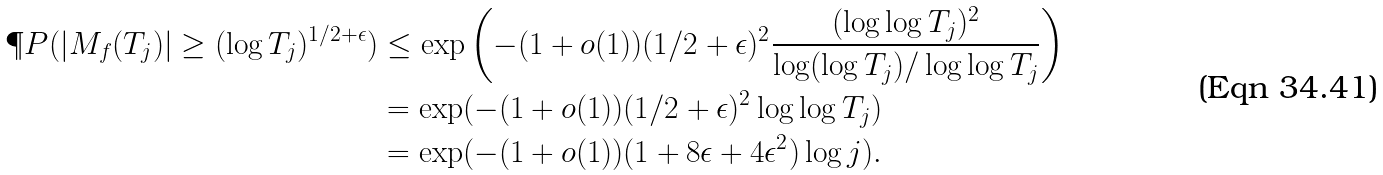<formula> <loc_0><loc_0><loc_500><loc_500>\P P ( | M _ { f } ( T _ { j } ) | \geq ( \log T _ { j } ) ^ { 1 / 2 + \epsilon } ) & \leq \exp \left ( - ( 1 + o ( 1 ) ) ( 1 / 2 + \epsilon ) ^ { 2 } \frac { ( \log \log T _ { j } ) ^ { 2 } } { \log ( \log T _ { j } ) / \log \log T _ { j } } \right ) \\ & = \exp ( - ( 1 + o ( 1 ) ) ( 1 / 2 + \epsilon ) ^ { 2 } \log \log T _ { j } ) \\ & = \exp ( - ( 1 + o ( 1 ) ) ( 1 + 8 \epsilon + 4 \epsilon ^ { 2 } ) \log j ) .</formula> 